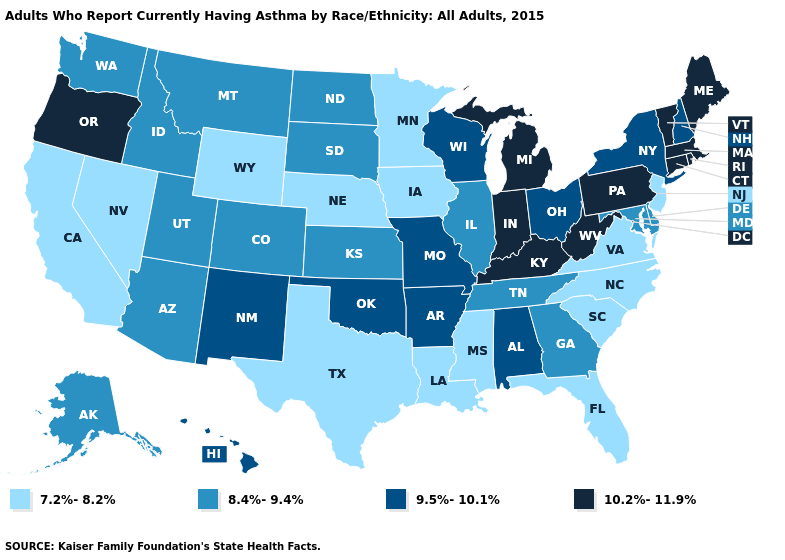Does the map have missing data?
Concise answer only. No. Name the states that have a value in the range 8.4%-9.4%?
Be succinct. Alaska, Arizona, Colorado, Delaware, Georgia, Idaho, Illinois, Kansas, Maryland, Montana, North Dakota, South Dakota, Tennessee, Utah, Washington. Among the states that border Kansas , which have the highest value?
Give a very brief answer. Missouri, Oklahoma. Which states hav the highest value in the West?
Concise answer only. Oregon. What is the value of New York?
Concise answer only. 9.5%-10.1%. Does Nevada have the lowest value in the USA?
Answer briefly. Yes. What is the value of Wisconsin?
Keep it brief. 9.5%-10.1%. Does Indiana have the highest value in the MidWest?
Short answer required. Yes. What is the highest value in the MidWest ?
Concise answer only. 10.2%-11.9%. Which states have the lowest value in the USA?
Concise answer only. California, Florida, Iowa, Louisiana, Minnesota, Mississippi, Nebraska, Nevada, New Jersey, North Carolina, South Carolina, Texas, Virginia, Wyoming. What is the highest value in the USA?
Answer briefly. 10.2%-11.9%. Name the states that have a value in the range 8.4%-9.4%?
Answer briefly. Alaska, Arizona, Colorado, Delaware, Georgia, Idaho, Illinois, Kansas, Maryland, Montana, North Dakota, South Dakota, Tennessee, Utah, Washington. Which states have the lowest value in the USA?
Write a very short answer. California, Florida, Iowa, Louisiana, Minnesota, Mississippi, Nebraska, Nevada, New Jersey, North Carolina, South Carolina, Texas, Virginia, Wyoming. Does California have the lowest value in the West?
Write a very short answer. Yes. Which states hav the highest value in the West?
Be succinct. Oregon. 